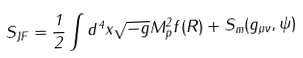Convert formula to latex. <formula><loc_0><loc_0><loc_500><loc_500>S _ { J F } = \frac { 1 } { 2 } \int d ^ { 4 } x \sqrt { - g } M _ { p } ^ { 2 } f ( R ) + S _ { m } ( g _ { \mu \nu } , \psi )</formula> 